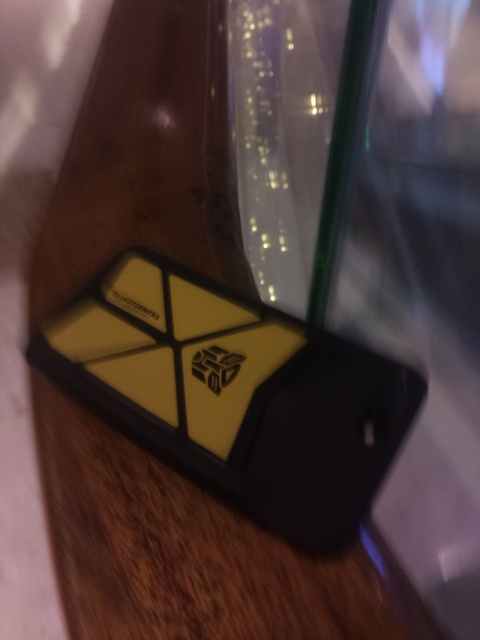What is the color scheme of the item? The item features a bold, dual-color scheme with a vivid yellow and black contrast, which catches the eye and adds a strong visual identity to the case. 